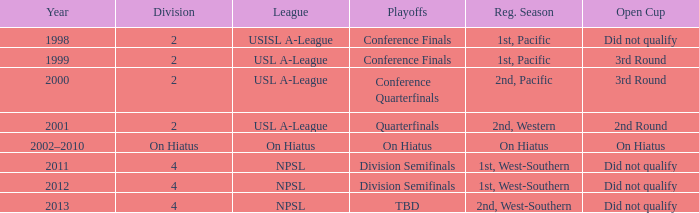Which playoffs took place during 2011? Division Semifinals. 